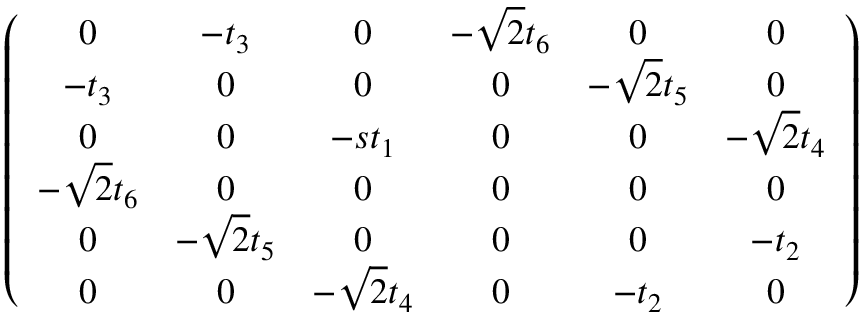<formula> <loc_0><loc_0><loc_500><loc_500>\begin{array} { r } { \left ( \begin{array} { c c c c c c } { 0 } & { - t _ { 3 } } & { 0 } & { - \sqrt { 2 } t _ { 6 } } & { 0 } & { 0 } \\ { - t _ { 3 } } & { 0 } & { 0 } & { 0 } & { - \sqrt { 2 } t _ { 5 } } & { 0 } \\ { 0 } & { 0 } & { - s t _ { 1 } } & { 0 } & { 0 } & { - \sqrt { 2 } t _ { 4 } } \\ { - \sqrt { 2 } t _ { 6 } } & { 0 } & { 0 } & { 0 } & { 0 } & { 0 } \\ { 0 } & { - \sqrt { 2 } t _ { 5 } } & { 0 } & { 0 } & { 0 } & { - t _ { 2 } } \\ { 0 } & { 0 } & { - \sqrt { 2 } t _ { 4 } } & { 0 } & { - t _ { 2 } } & { 0 } \end{array} \right ) } \end{array}</formula> 